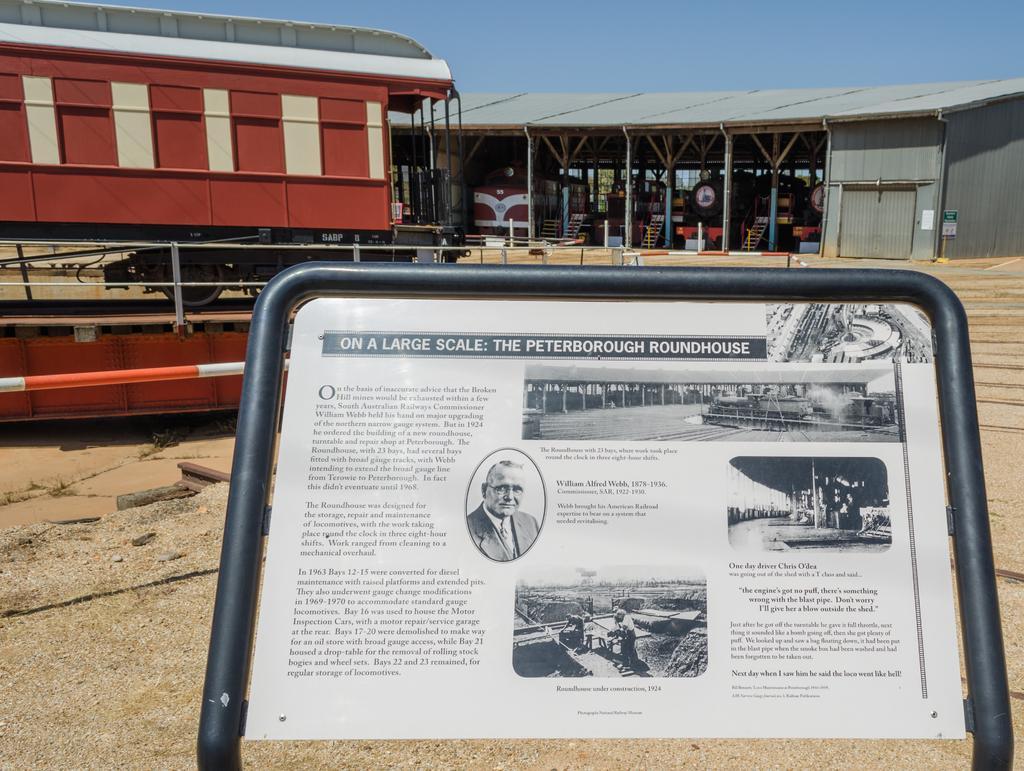Can you describe this image briefly? In the foreground of the image there is board with some text. In the background of the image there is shed. There are train engines. To the left side of the image there is a vehicle. At the bottom of the image there is surface. 